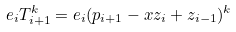Convert formula to latex. <formula><loc_0><loc_0><loc_500><loc_500>e _ { i } T _ { i + 1 } ^ { k } = e _ { i } ( p _ { i + 1 } - x z _ { i } + z _ { i - 1 } ) ^ { k }</formula> 